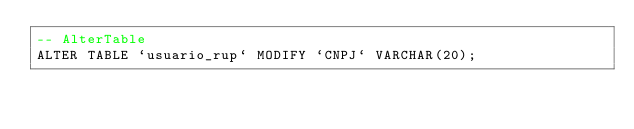<code> <loc_0><loc_0><loc_500><loc_500><_SQL_>-- AlterTable
ALTER TABLE `usuario_rup` MODIFY `CNPJ` VARCHAR(20);
</code> 